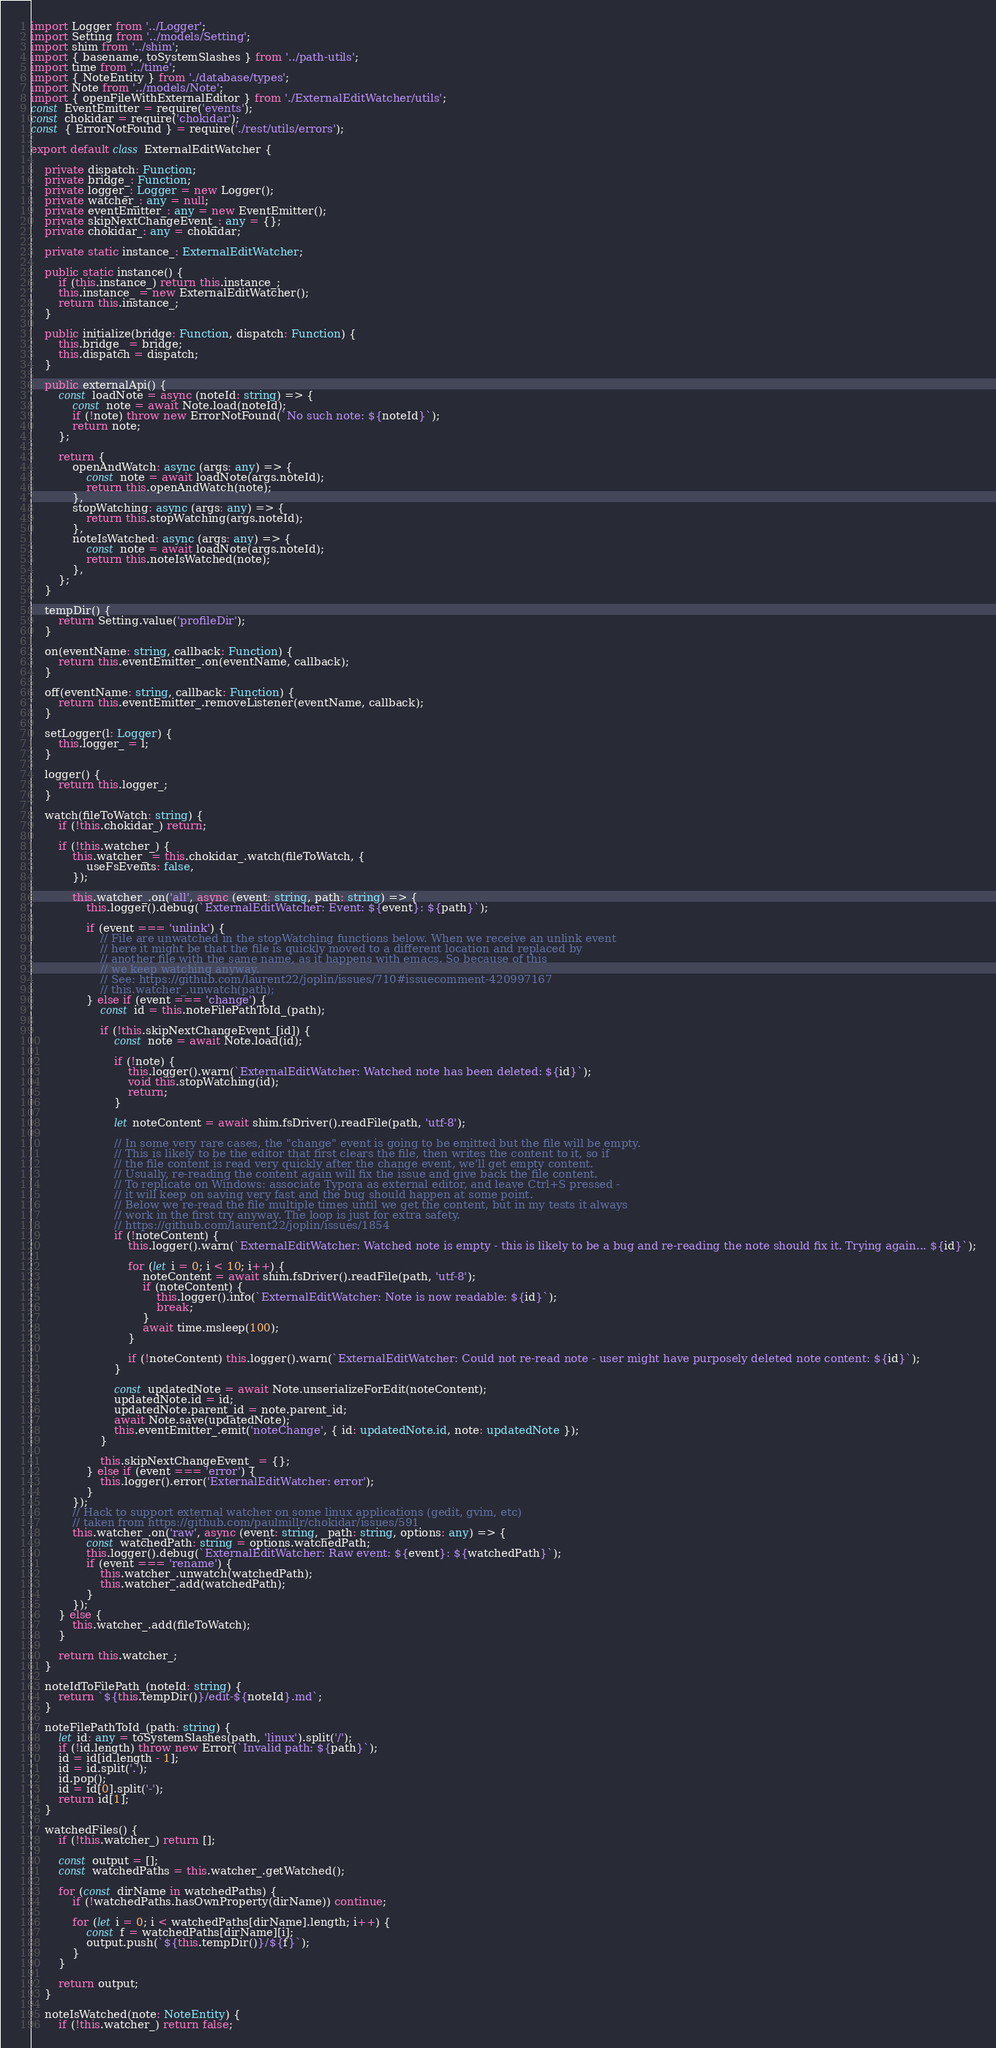Convert code to text. <code><loc_0><loc_0><loc_500><loc_500><_TypeScript_>import Logger from '../Logger';
import Setting from '../models/Setting';
import shim from '../shim';
import { basename, toSystemSlashes } from '../path-utils';
import time from '../time';
import { NoteEntity } from './database/types';
import Note from '../models/Note';
import { openFileWithExternalEditor } from './ExternalEditWatcher/utils';
const EventEmitter = require('events');
const chokidar = require('chokidar');
const { ErrorNotFound } = require('./rest/utils/errors');

export default class ExternalEditWatcher {

	private dispatch: Function;
	private bridge_: Function;
	private logger_: Logger = new Logger();
	private watcher_: any = null;
	private eventEmitter_: any = new EventEmitter();
	private skipNextChangeEvent_: any = {};
	private chokidar_: any = chokidar;

	private static instance_: ExternalEditWatcher;

	public static instance() {
		if (this.instance_) return this.instance_;
		this.instance_ = new ExternalEditWatcher();
		return this.instance_;
	}

	public initialize(bridge: Function, dispatch: Function) {
		this.bridge_ = bridge;
		this.dispatch = dispatch;
	}

	public externalApi() {
		const loadNote = async (noteId: string) => {
			const note = await Note.load(noteId);
			if (!note) throw new ErrorNotFound(`No such note: ${noteId}`);
			return note;
		};

		return {
			openAndWatch: async (args: any) => {
				const note = await loadNote(args.noteId);
				return this.openAndWatch(note);
			},
			stopWatching: async (args: any) => {
				return this.stopWatching(args.noteId);
			},
			noteIsWatched: async (args: any) => {
				const note = await loadNote(args.noteId);
				return this.noteIsWatched(note);
			},
		};
	}

	tempDir() {
		return Setting.value('profileDir');
	}

	on(eventName: string, callback: Function) {
		return this.eventEmitter_.on(eventName, callback);
	}

	off(eventName: string, callback: Function) {
		return this.eventEmitter_.removeListener(eventName, callback);
	}

	setLogger(l: Logger) {
		this.logger_ = l;
	}

	logger() {
		return this.logger_;
	}

	watch(fileToWatch: string) {
		if (!this.chokidar_) return;

		if (!this.watcher_) {
			this.watcher_ = this.chokidar_.watch(fileToWatch, {
				useFsEvents: false,
			});

			this.watcher_.on('all', async (event: string, path: string) => {
				this.logger().debug(`ExternalEditWatcher: Event: ${event}: ${path}`);

				if (event === 'unlink') {
					// File are unwatched in the stopWatching functions below. When we receive an unlink event
					// here it might be that the file is quickly moved to a different location and replaced by
					// another file with the same name, as it happens with emacs. So because of this
					// we keep watching anyway.
					// See: https://github.com/laurent22/joplin/issues/710#issuecomment-420997167
					// this.watcher_.unwatch(path);
				} else if (event === 'change') {
					const id = this.noteFilePathToId_(path);

					if (!this.skipNextChangeEvent_[id]) {
						const note = await Note.load(id);

						if (!note) {
							this.logger().warn(`ExternalEditWatcher: Watched note has been deleted: ${id}`);
							void this.stopWatching(id);
							return;
						}

						let noteContent = await shim.fsDriver().readFile(path, 'utf-8');

						// In some very rare cases, the "change" event is going to be emitted but the file will be empty.
						// This is likely to be the editor that first clears the file, then writes the content to it, so if
						// the file content is read very quickly after the change event, we'll get empty content.
						// Usually, re-reading the content again will fix the issue and give back the file content.
						// To replicate on Windows: associate Typora as external editor, and leave Ctrl+S pressed -
						// it will keep on saving very fast and the bug should happen at some point.
						// Below we re-read the file multiple times until we get the content, but in my tests it always
						// work in the first try anyway. The loop is just for extra safety.
						// https://github.com/laurent22/joplin/issues/1854
						if (!noteContent) {
							this.logger().warn(`ExternalEditWatcher: Watched note is empty - this is likely to be a bug and re-reading the note should fix it. Trying again... ${id}`);

							for (let i = 0; i < 10; i++) {
								noteContent = await shim.fsDriver().readFile(path, 'utf-8');
								if (noteContent) {
									this.logger().info(`ExternalEditWatcher: Note is now readable: ${id}`);
									break;
								}
								await time.msleep(100);
							}

							if (!noteContent) this.logger().warn(`ExternalEditWatcher: Could not re-read note - user might have purposely deleted note content: ${id}`);
						}

						const updatedNote = await Note.unserializeForEdit(noteContent);
						updatedNote.id = id;
						updatedNote.parent_id = note.parent_id;
						await Note.save(updatedNote);
						this.eventEmitter_.emit('noteChange', { id: updatedNote.id, note: updatedNote });
					}

					this.skipNextChangeEvent_ = {};
				} else if (event === 'error') {
					this.logger().error('ExternalEditWatcher: error');
				}
			});
			// Hack to support external watcher on some linux applications (gedit, gvim, etc)
			// taken from https://github.com/paulmillr/chokidar/issues/591
			this.watcher_.on('raw', async (event: string, _path: string, options: any) => {
				const watchedPath: string = options.watchedPath;
				this.logger().debug(`ExternalEditWatcher: Raw event: ${event}: ${watchedPath}`);
				if (event === 'rename') {
					this.watcher_.unwatch(watchedPath);
					this.watcher_.add(watchedPath);
				}
			});
		} else {
			this.watcher_.add(fileToWatch);
		}

		return this.watcher_;
	}

	noteIdToFilePath_(noteId: string) {
		return `${this.tempDir()}/edit-${noteId}.md`;
	}

	noteFilePathToId_(path: string) {
		let id: any = toSystemSlashes(path, 'linux').split('/');
		if (!id.length) throw new Error(`Invalid path: ${path}`);
		id = id[id.length - 1];
		id = id.split('.');
		id.pop();
		id = id[0].split('-');
		return id[1];
	}

	watchedFiles() {
		if (!this.watcher_) return [];

		const output = [];
		const watchedPaths = this.watcher_.getWatched();

		for (const dirName in watchedPaths) {
			if (!watchedPaths.hasOwnProperty(dirName)) continue;

			for (let i = 0; i < watchedPaths[dirName].length; i++) {
				const f = watchedPaths[dirName][i];
				output.push(`${this.tempDir()}/${f}`);
			}
		}

		return output;
	}

	noteIsWatched(note: NoteEntity) {
		if (!this.watcher_) return false;
</code> 